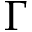Convert formula to latex. <formula><loc_0><loc_0><loc_500><loc_500>\Gamma</formula> 